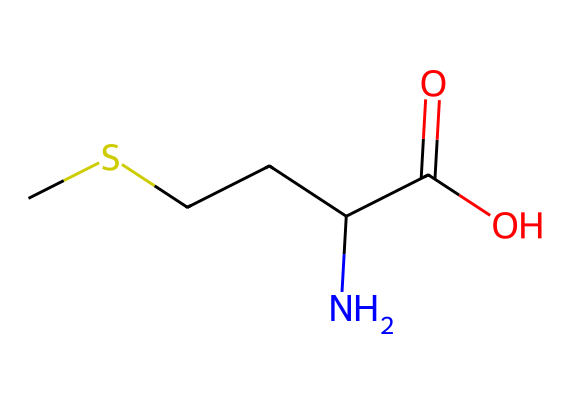What is the molecular formula of methionine? The SMILES representation indicates the atoms present: one sulfur (S), five carbons (C), eleven hydrogens (H), one nitrogen (N), and two oxygens (O). The molecular formula can be calculated as C5H11NO2S.
Answer: C5H11NO2S How many chiral centers are present in methionine? Examining the structure, there is one carbon atom connected to four different groups (the amino group, the carboxylic acid group, the sulfur-containing side chain, and the hydrogen), indicating one chiral center.
Answer: 1 What type of functional groups are present in methionine? The chemical has a carboxylic acid group (–COOH), an amine group (–NH2), and a thioether (the sulfur atom in the side chain), indicating multiple functional groups.
Answer: carboxylic acid, amine, and thioether Is methionine hydrophobic or hydrophilic? The presence of the sulfur atom in the thioether group and the non-polar carbon chain suggests a hydrophobic character, although the carboxylic acid and amine groups can impart some hydrophilicity, making it somewhat amphipathic. However, the overall hydrophobic influence is stronger due to the larger non-polar chain.
Answer: hydrophobic What role does methionine play in the body? Methionine is an essential amino acid, meaning it is necessary for various cellular functions and cannot be synthesized by the body; it must be obtained through diet. It plays a crucial role in protein synthesis and acts as a precursor for other important compounds like cysteine and SAMe (S-adenosylmethionine).
Answer: essential amino acid What is the significance of the sulfur atom in methionine? The sulfur atom is significant as it contributes to the formation of disulfide bonds in proteins, which are crucial for the stability and functionality of many proteins. Additionally, methionine serves as a precursor in the biosynthesis of other sulfur-containing amino acids and metabolites.
Answer: disulfide bond formation 